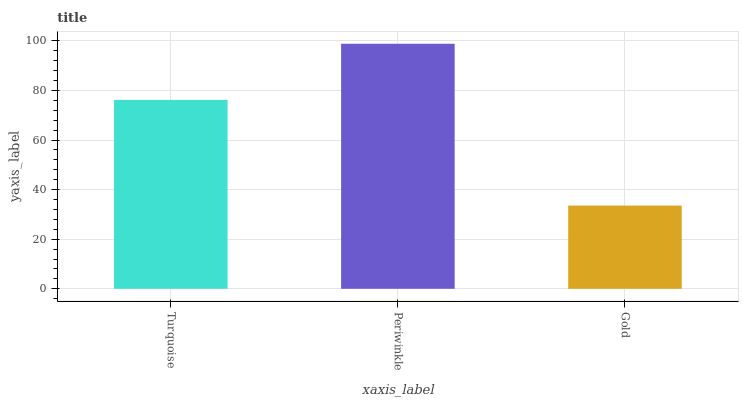Is Gold the minimum?
Answer yes or no. Yes. Is Periwinkle the maximum?
Answer yes or no. Yes. Is Periwinkle the minimum?
Answer yes or no. No. Is Gold the maximum?
Answer yes or no. No. Is Periwinkle greater than Gold?
Answer yes or no. Yes. Is Gold less than Periwinkle?
Answer yes or no. Yes. Is Gold greater than Periwinkle?
Answer yes or no. No. Is Periwinkle less than Gold?
Answer yes or no. No. Is Turquoise the high median?
Answer yes or no. Yes. Is Turquoise the low median?
Answer yes or no. Yes. Is Periwinkle the high median?
Answer yes or no. No. Is Periwinkle the low median?
Answer yes or no. No. 